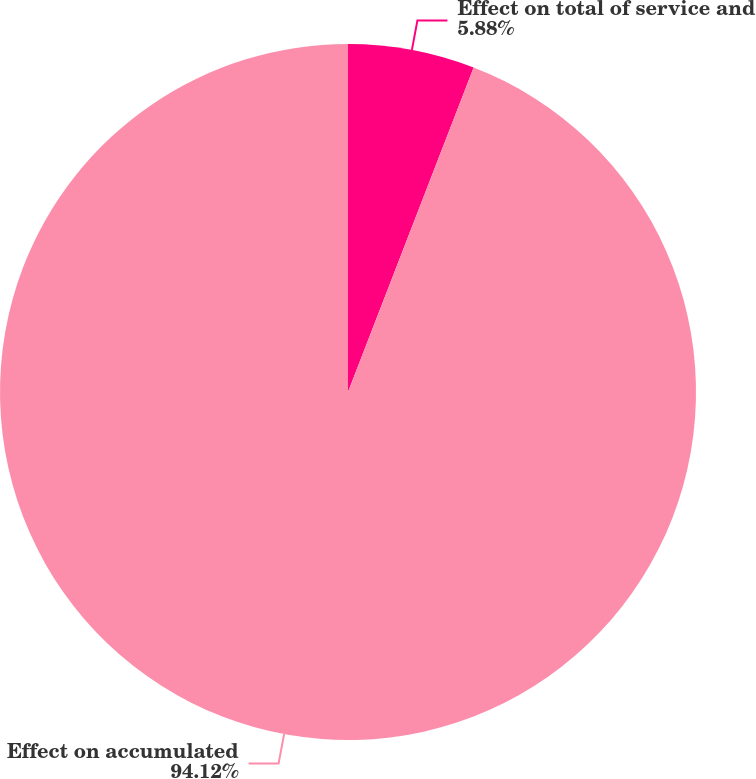<chart> <loc_0><loc_0><loc_500><loc_500><pie_chart><fcel>Effect on total of service and<fcel>Effect on accumulated<nl><fcel>5.88%<fcel>94.12%<nl></chart> 